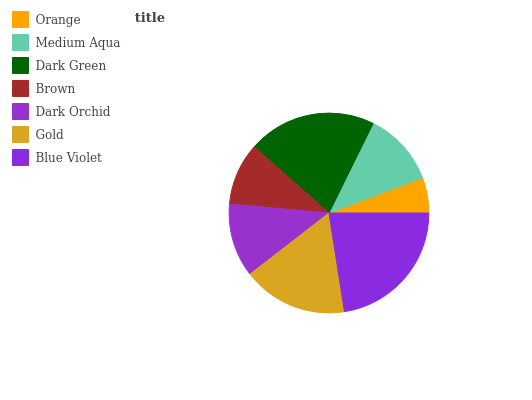Is Orange the minimum?
Answer yes or no. Yes. Is Blue Violet the maximum?
Answer yes or no. Yes. Is Medium Aqua the minimum?
Answer yes or no. No. Is Medium Aqua the maximum?
Answer yes or no. No. Is Medium Aqua greater than Orange?
Answer yes or no. Yes. Is Orange less than Medium Aqua?
Answer yes or no. Yes. Is Orange greater than Medium Aqua?
Answer yes or no. No. Is Medium Aqua less than Orange?
Answer yes or no. No. Is Medium Aqua the high median?
Answer yes or no. Yes. Is Medium Aqua the low median?
Answer yes or no. Yes. Is Orange the high median?
Answer yes or no. No. Is Blue Violet the low median?
Answer yes or no. No. 